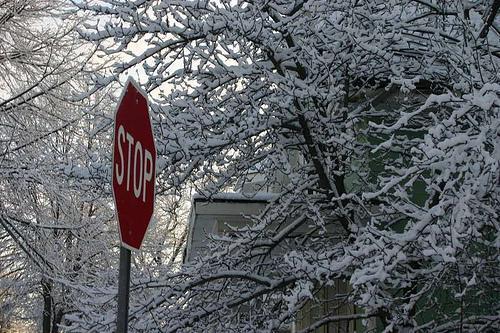How many giraffes are sitting?
Give a very brief answer. 0. 